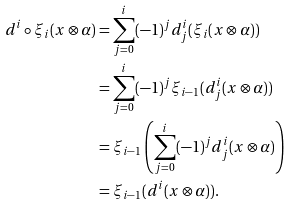<formula> <loc_0><loc_0><loc_500><loc_500>d ^ { i } \circ \xi _ { i } ( x \otimes \alpha ) & = \sum _ { j = 0 } ^ { i } ( - 1 ) ^ { j } d ^ { i } _ { j } ( \xi _ { i } ( x \otimes \alpha ) ) \\ & = \sum _ { j = 0 } ^ { i } ( - 1 ) ^ { j } \xi _ { i - 1 } ( d ^ { i } _ { j } ( x \otimes \alpha ) ) \\ & = \xi _ { i - 1 } \left ( \sum _ { j = 0 } ^ { i } ( - 1 ) ^ { j } d ^ { i } _ { j } ( x \otimes \alpha ) \right ) \\ & = \xi _ { i - 1 } ( d ^ { i } ( x \otimes \alpha ) ) .</formula> 